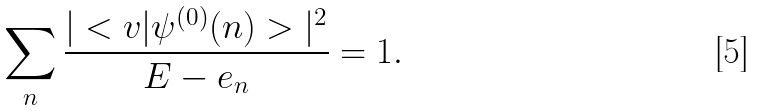Convert formula to latex. <formula><loc_0><loc_0><loc_500><loc_500>\sum _ { n } \frac { | < v | \psi ^ { ( 0 ) } ( n ) > | ^ { 2 } } { E - e _ { n } } = 1 .</formula> 